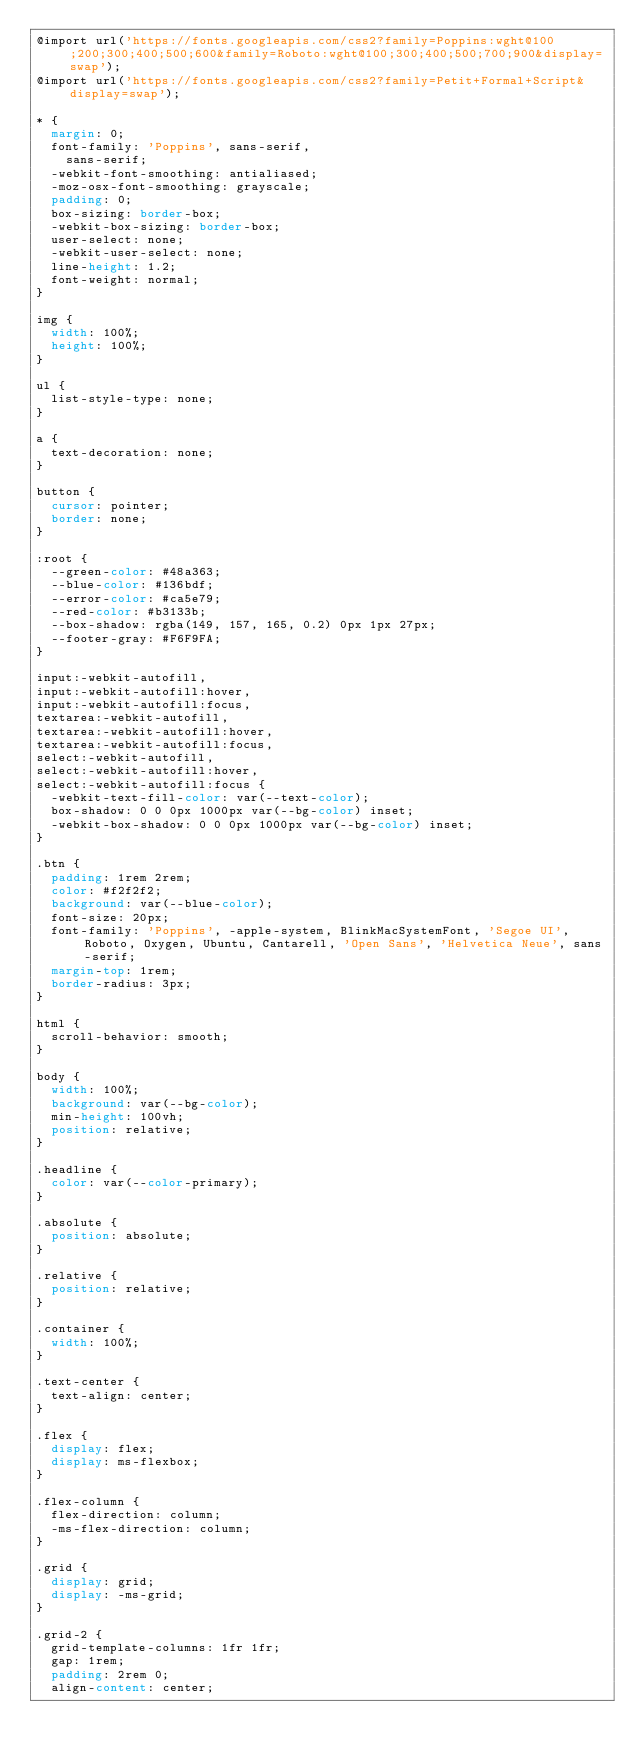<code> <loc_0><loc_0><loc_500><loc_500><_CSS_>@import url('https://fonts.googleapis.com/css2?family=Poppins:wght@100;200;300;400;500;600&family=Roboto:wght@100;300;400;500;700;900&display=swap');
@import url('https://fonts.googleapis.com/css2?family=Petit+Formal+Script&display=swap');

* {
  margin: 0;
  font-family: 'Poppins', sans-serif,
    sans-serif;
  -webkit-font-smoothing: antialiased;
  -moz-osx-font-smoothing: grayscale;
  padding: 0;
  box-sizing: border-box;
  -webkit-box-sizing: border-box;
  user-select: none;
  -webkit-user-select: none;
  line-height: 1.2;
  font-weight: normal;
}

img {
  width: 100%;
  height: 100%;
}

ul {
  list-style-type: none;
}

a {
  text-decoration: none;
}

button {
  cursor: pointer;
  border: none;
}

:root {
  --green-color: #48a363;
  --blue-color: #136bdf;
  --error-color: #ca5e79;
  --red-color: #b3133b;
  --box-shadow: rgba(149, 157, 165, 0.2) 0px 1px 27px;
  --footer-gray: #F6F9FA;
}

input:-webkit-autofill,
input:-webkit-autofill:hover, 
input:-webkit-autofill:focus,
textarea:-webkit-autofill,
textarea:-webkit-autofill:hover,
textarea:-webkit-autofill:focus,
select:-webkit-autofill,
select:-webkit-autofill:hover,
select:-webkit-autofill:focus {
  -webkit-text-fill-color: var(--text-color);
  box-shadow: 0 0 0px 1000px var(--bg-color) inset;
  -webkit-box-shadow: 0 0 0px 1000px var(--bg-color) inset;
}

.btn {
  padding: 1rem 2rem;
  color: #f2f2f2;
  background: var(--blue-color);
  font-size: 20px;
  font-family: 'Poppins', -apple-system, BlinkMacSystemFont, 'Segoe UI', Roboto, Oxygen, Ubuntu, Cantarell, 'Open Sans', 'Helvetica Neue', sans-serif;
  margin-top: 1rem;
  border-radius: 3px;
}

html {
  scroll-behavior: smooth;
}

body {
  width: 100%;
  background: var(--bg-color);
  min-height: 100vh;
  position: relative;
}

.headline {
  color: var(--color-primary);
}

.absolute {
  position: absolute;
}

.relative {
  position: relative;
}

.container {
  width: 100%;
}

.text-center {
  text-align: center;
}

.flex {
  display: flex;
  display: ms-flexbox;
}

.flex-column {
  flex-direction: column;
  -ms-flex-direction: column;
}

.grid {
  display: grid;
  display: -ms-grid;
}

.grid-2 {
  grid-template-columns: 1fr 1fr;
  gap: 1rem;
  padding: 2rem 0;
  align-content: center;</code> 